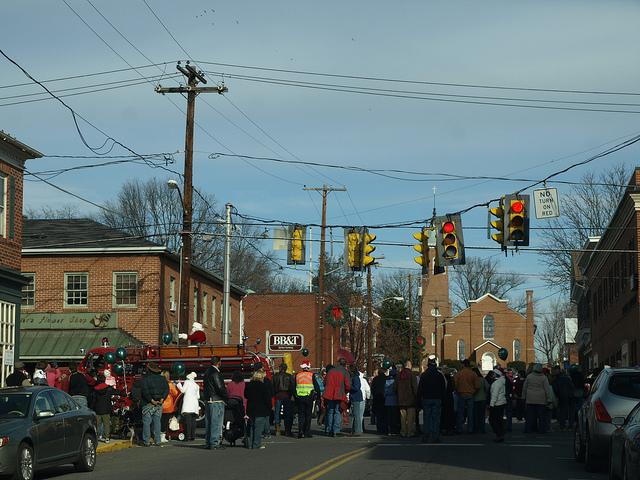Why are people in the middle of the street? parade 